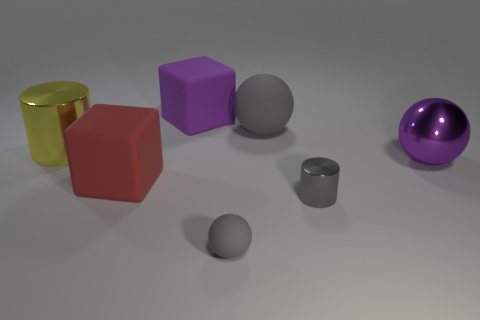Add 2 gray spheres. How many objects exist? 9 Subtract all blocks. How many objects are left? 5 Subtract all gray objects. Subtract all tiny yellow balls. How many objects are left? 4 Add 6 purple metallic balls. How many purple metallic balls are left? 7 Add 1 small blue cubes. How many small blue cubes exist? 1 Subtract 0 blue cylinders. How many objects are left? 7 